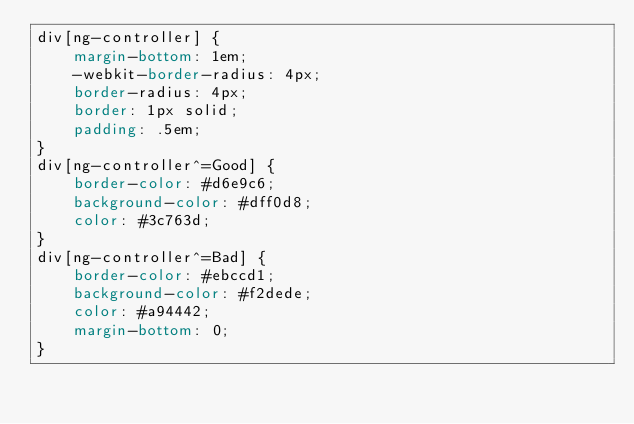<code> <loc_0><loc_0><loc_500><loc_500><_CSS_>div[ng-controller] {
    margin-bottom: 1em;
    -webkit-border-radius: 4px;
    border-radius: 4px;
    border: 1px solid;
    padding: .5em;
}
div[ng-controller^=Good] {
    border-color: #d6e9c6;
    background-color: #dff0d8;
    color: #3c763d;
}
div[ng-controller^=Bad] {
    border-color: #ebccd1;
    background-color: #f2dede;
    color: #a94442;
    margin-bottom: 0;
}</code> 